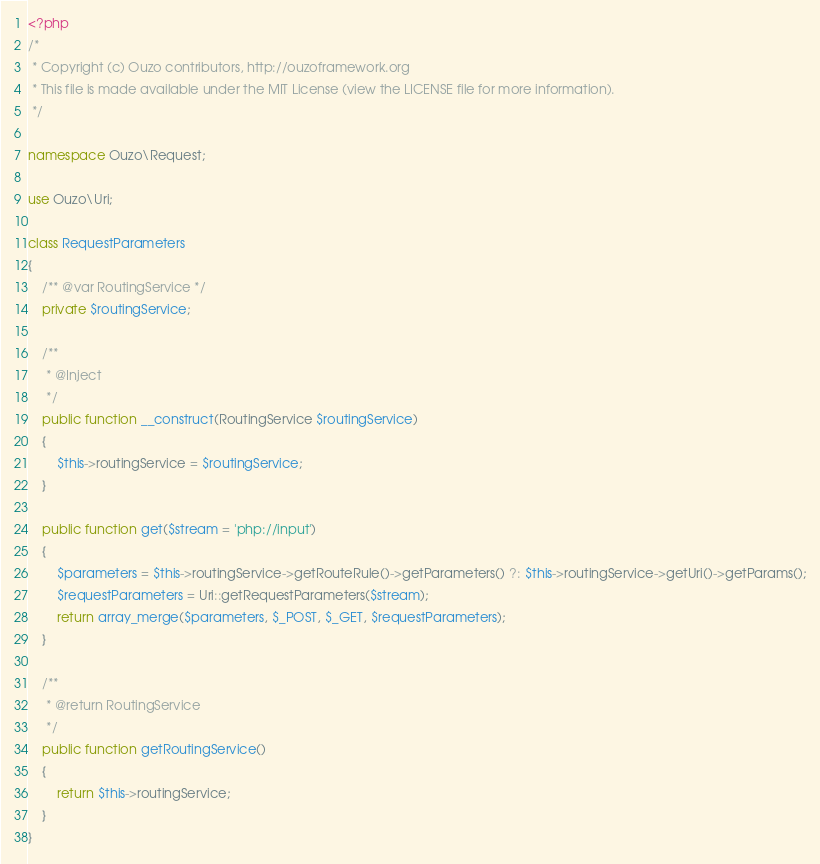<code> <loc_0><loc_0><loc_500><loc_500><_PHP_><?php
/*
 * Copyright (c) Ouzo contributors, http://ouzoframework.org
 * This file is made available under the MIT License (view the LICENSE file for more information).
 */

namespace Ouzo\Request;

use Ouzo\Uri;

class RequestParameters
{
    /** @var RoutingService */
    private $routingService;

    /**
     * @Inject
     */
    public function __construct(RoutingService $routingService)
    {
        $this->routingService = $routingService;
    }

    public function get($stream = 'php://input')
    {
        $parameters = $this->routingService->getRouteRule()->getParameters() ?: $this->routingService->getUri()->getParams();
        $requestParameters = Uri::getRequestParameters($stream);
        return array_merge($parameters, $_POST, $_GET, $requestParameters);
    }

    /**
     * @return RoutingService
     */
    public function getRoutingService()
    {
        return $this->routingService;
    }
}
</code> 